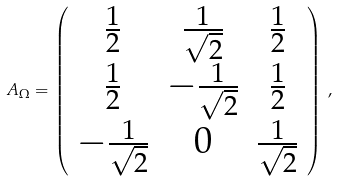Convert formula to latex. <formula><loc_0><loc_0><loc_500><loc_500>A _ { \Omega } = \left ( \begin{array} { c c c c } \frac { 1 } { 2 } & \frac { 1 } { \sqrt { 2 } } & \frac { 1 } { 2 } \\ \frac { 1 } { 2 } & - \frac { 1 } { \sqrt { 2 } } & \frac { 1 } { 2 } \\ - \frac { 1 } { \sqrt { 2 } } & 0 & \frac { 1 } { \sqrt { 2 } } \end{array} \right ) \, ,</formula> 